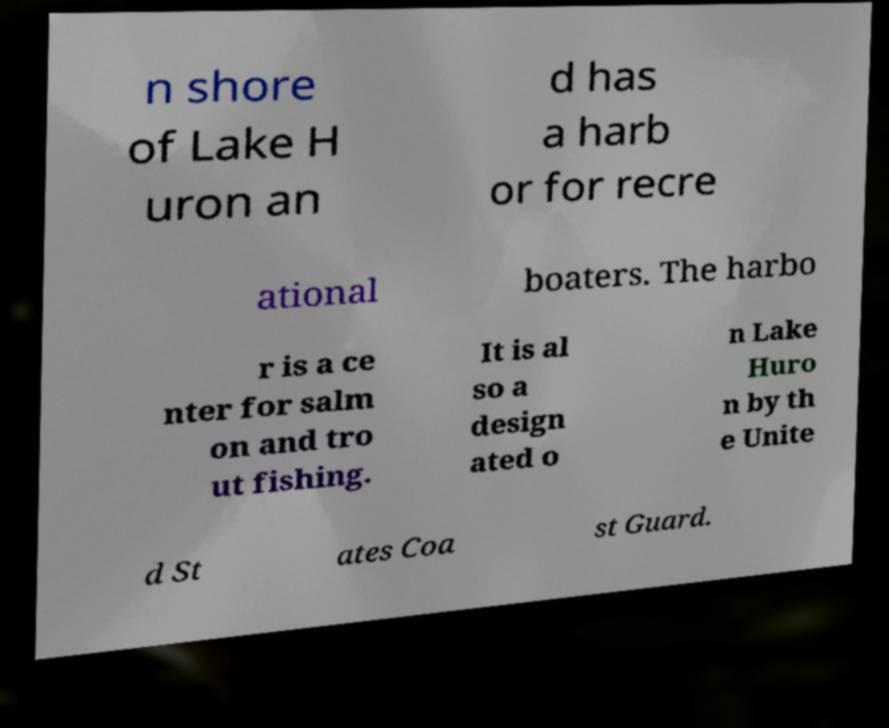Please read and relay the text visible in this image. What does it say? n shore of Lake H uron an d has a harb or for recre ational boaters. The harbo r is a ce nter for salm on and tro ut fishing. It is al so a design ated o n Lake Huro n by th e Unite d St ates Coa st Guard. 